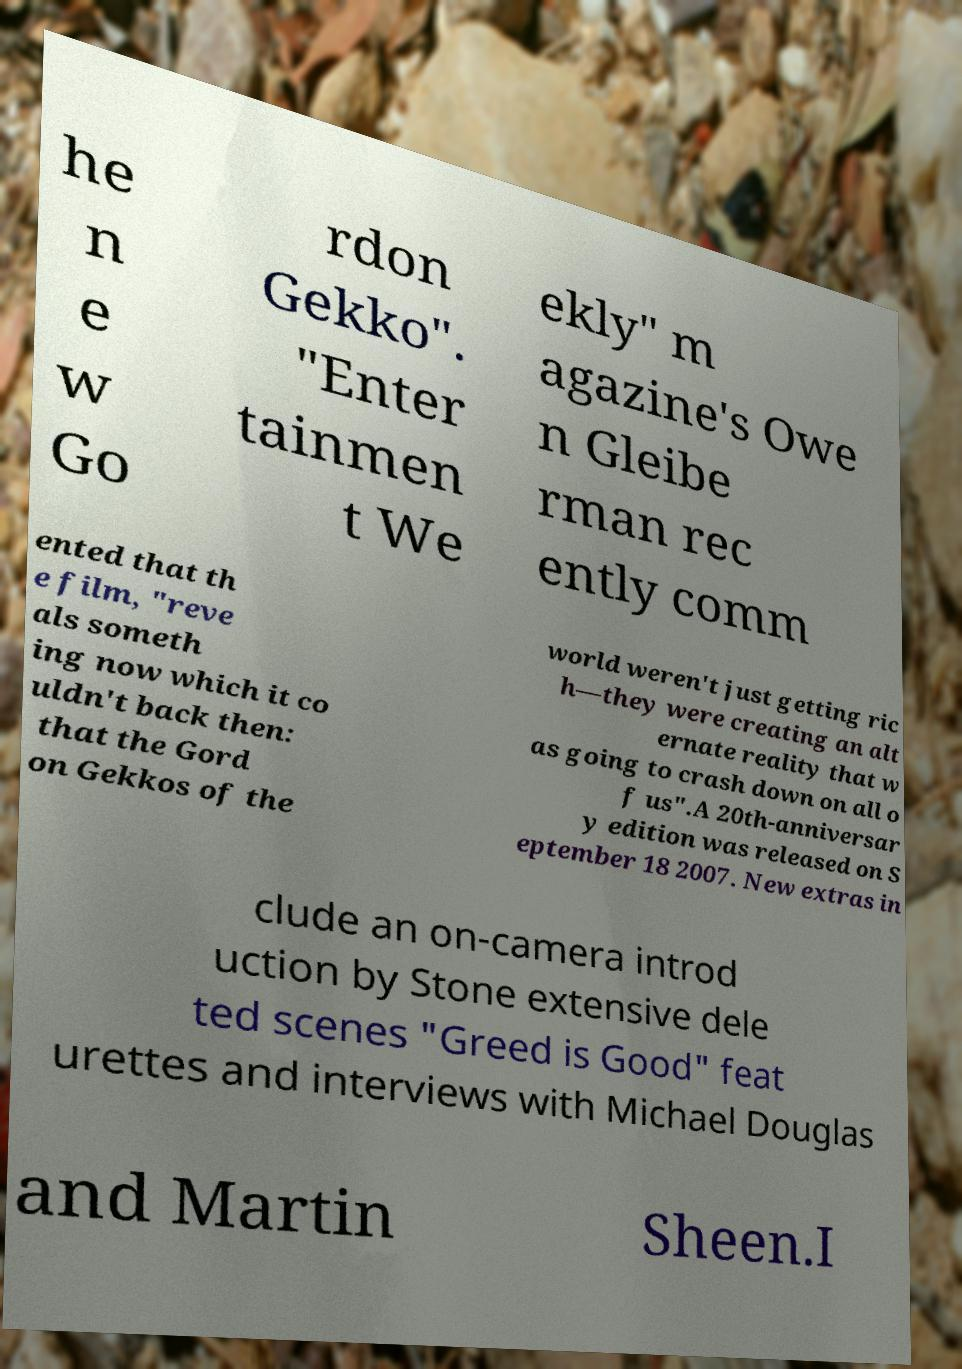Can you read and provide the text displayed in the image?This photo seems to have some interesting text. Can you extract and type it out for me? he n e w Go rdon Gekko". "Enter tainmen t We ekly" m agazine's Owe n Gleibe rman rec ently comm ented that th e film, "reve als someth ing now which it co uldn't back then: that the Gord on Gekkos of the world weren't just getting ric h—they were creating an alt ernate reality that w as going to crash down on all o f us".A 20th-anniversar y edition was released on S eptember 18 2007. New extras in clude an on-camera introd uction by Stone extensive dele ted scenes "Greed is Good" feat urettes and interviews with Michael Douglas and Martin Sheen.I 